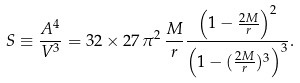Convert formula to latex. <formula><loc_0><loc_0><loc_500><loc_500>S \equiv \frac { A ^ { 4 } } { V ^ { 3 } } = 3 2 \times 2 7 \, \pi ^ { 2 } \, \frac { M } { r } \frac { \left ( 1 - \frac { 2 M } { r } \right ) ^ { 2 } } { \left ( 1 - ( \frac { 2 M } { r } ) ^ { 3 } \right ) ^ { 3 } } .</formula> 